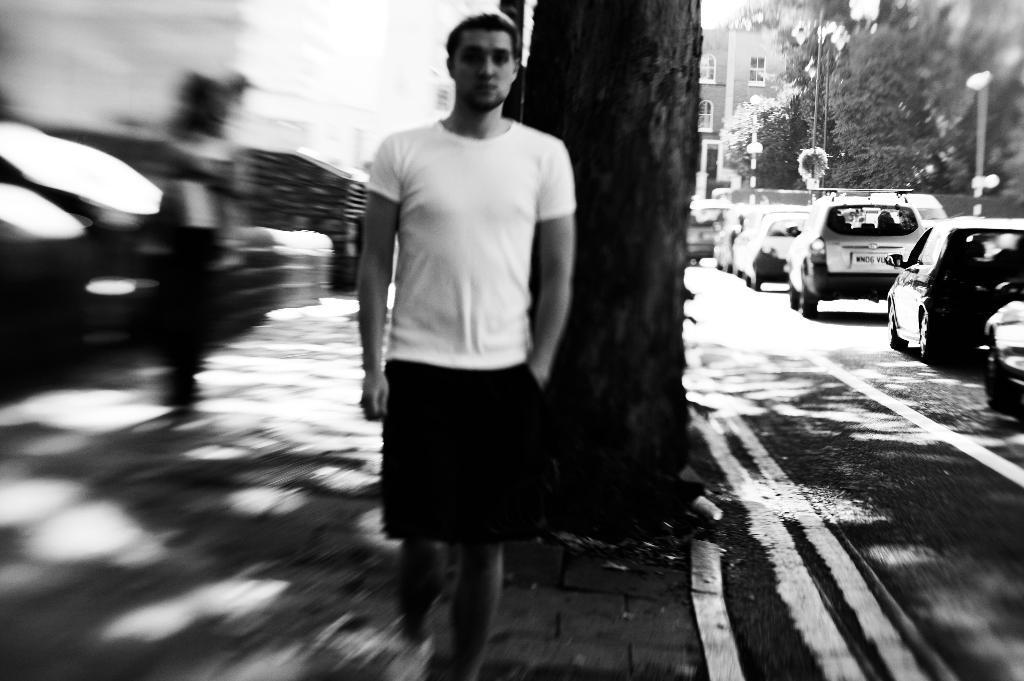Please provide a concise description of this image. In this picture we can see a man in the front, on the right side there are some cars, trees, a building and a pole, there is a blurry background, it is a black and white image. 